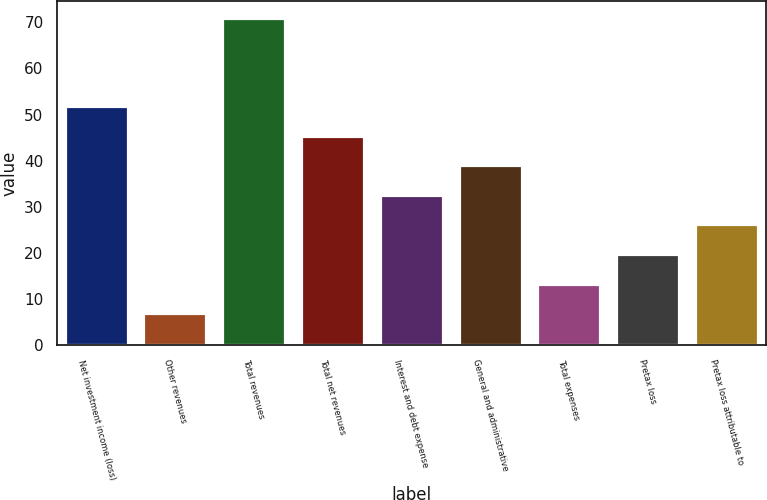<chart> <loc_0><loc_0><loc_500><loc_500><bar_chart><fcel>Net investment income (loss)<fcel>Other revenues<fcel>Total revenues<fcel>Total net revenues<fcel>Interest and debt expense<fcel>General and administrative<fcel>Total expenses<fcel>Pretax loss<fcel>Pretax loss attributable to<nl><fcel>51.8<fcel>7<fcel>71<fcel>45.4<fcel>32.6<fcel>39<fcel>13.4<fcel>19.8<fcel>26.2<nl></chart> 